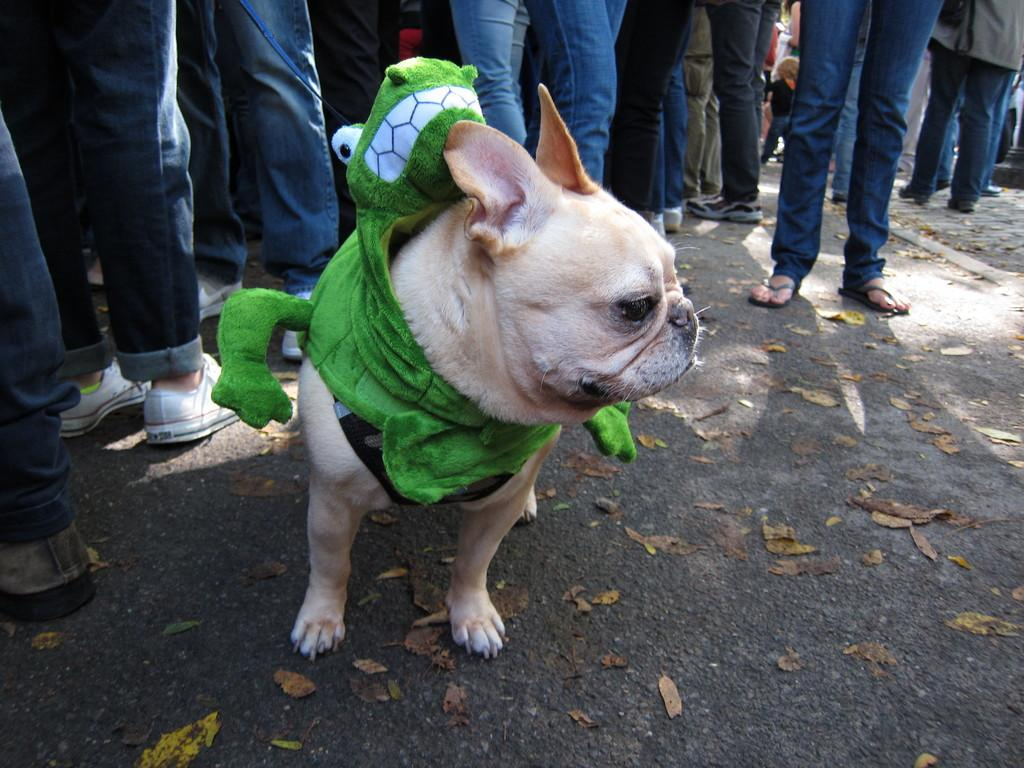What animal is present in the image? There is a dog in the image. Where is the dog located? The dog is standing on the road. What is attached to the dog? There is a toy tied to the dog. Can you describe the background of the image? There are legs of people visible in the background of the image. What type of range can be seen in the image? There is no range present in the image; it features a dog standing on the road with a toy tied to it and people's legs visible in the background. 